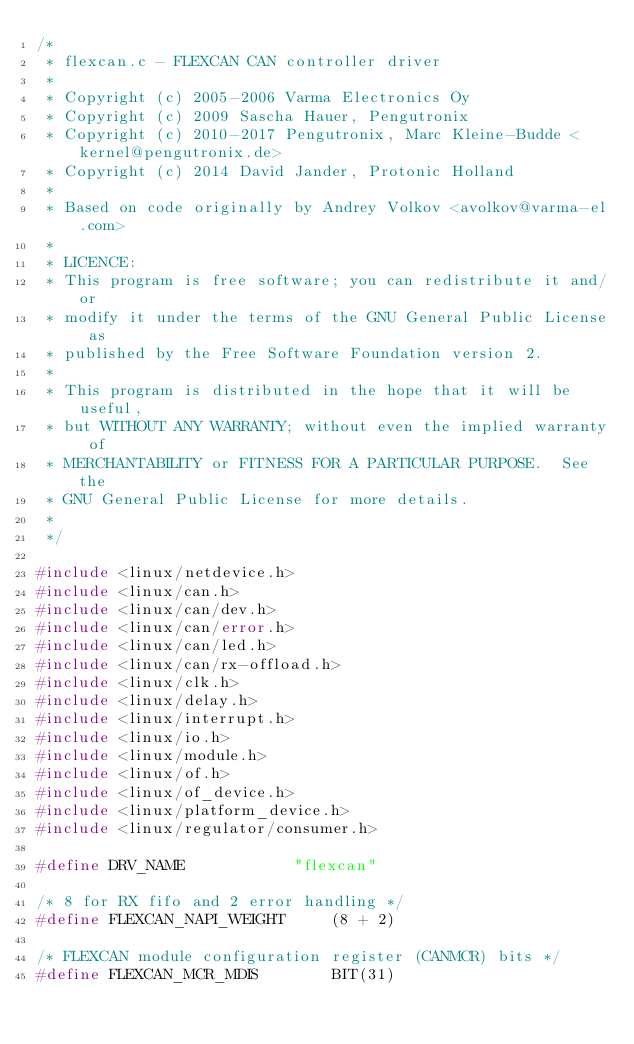<code> <loc_0><loc_0><loc_500><loc_500><_C_>/*
 * flexcan.c - FLEXCAN CAN controller driver
 *
 * Copyright (c) 2005-2006 Varma Electronics Oy
 * Copyright (c) 2009 Sascha Hauer, Pengutronix
 * Copyright (c) 2010-2017 Pengutronix, Marc Kleine-Budde <kernel@pengutronix.de>
 * Copyright (c) 2014 David Jander, Protonic Holland
 *
 * Based on code originally by Andrey Volkov <avolkov@varma-el.com>
 *
 * LICENCE:
 * This program is free software; you can redistribute it and/or
 * modify it under the terms of the GNU General Public License as
 * published by the Free Software Foundation version 2.
 *
 * This program is distributed in the hope that it will be useful,
 * but WITHOUT ANY WARRANTY; without even the implied warranty of
 * MERCHANTABILITY or FITNESS FOR A PARTICULAR PURPOSE.  See the
 * GNU General Public License for more details.
 *
 */

#include <linux/netdevice.h>
#include <linux/can.h>
#include <linux/can/dev.h>
#include <linux/can/error.h>
#include <linux/can/led.h>
#include <linux/can/rx-offload.h>
#include <linux/clk.h>
#include <linux/delay.h>
#include <linux/interrupt.h>
#include <linux/io.h>
#include <linux/module.h>
#include <linux/of.h>
#include <linux/of_device.h>
#include <linux/platform_device.h>
#include <linux/regulator/consumer.h>

#define DRV_NAME			"flexcan"

/* 8 for RX fifo and 2 error handling */
#define FLEXCAN_NAPI_WEIGHT		(8 + 2)

/* FLEXCAN module configuration register (CANMCR) bits */
#define FLEXCAN_MCR_MDIS		BIT(31)</code> 